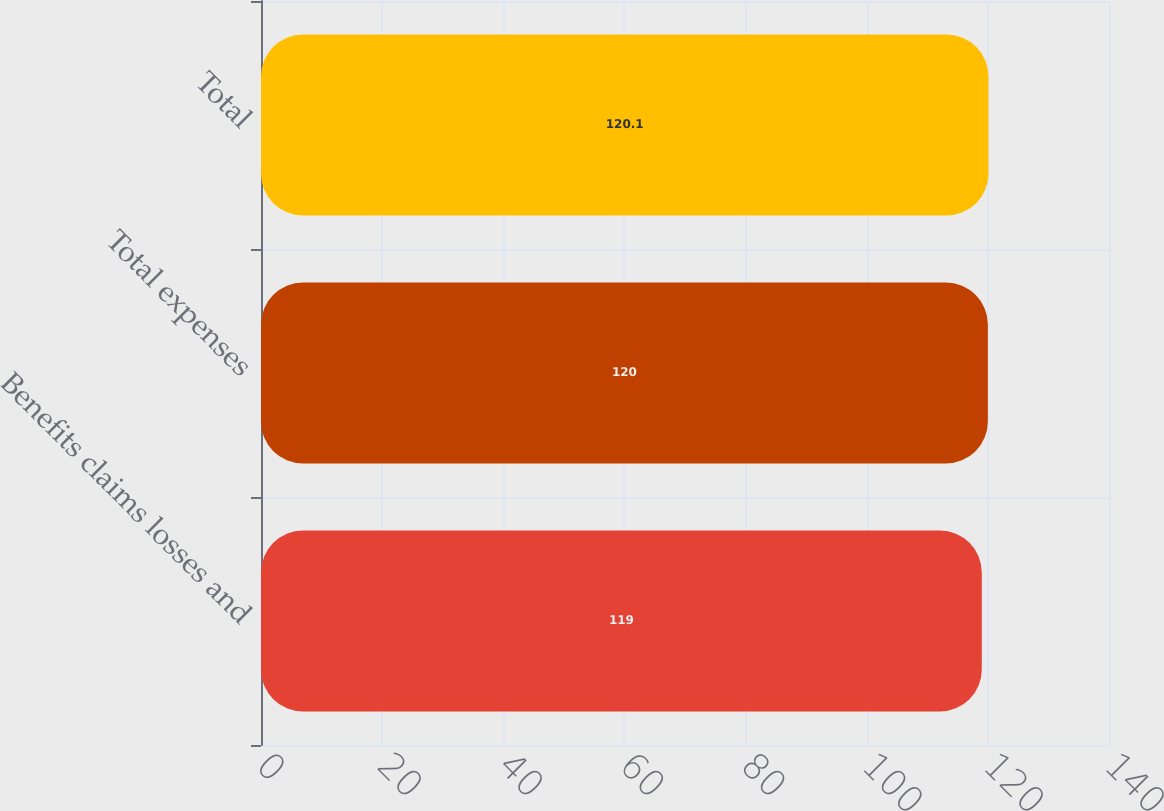<chart> <loc_0><loc_0><loc_500><loc_500><bar_chart><fcel>Benefits claims losses and<fcel>Total expenses<fcel>Total<nl><fcel>119<fcel>120<fcel>120.1<nl></chart> 